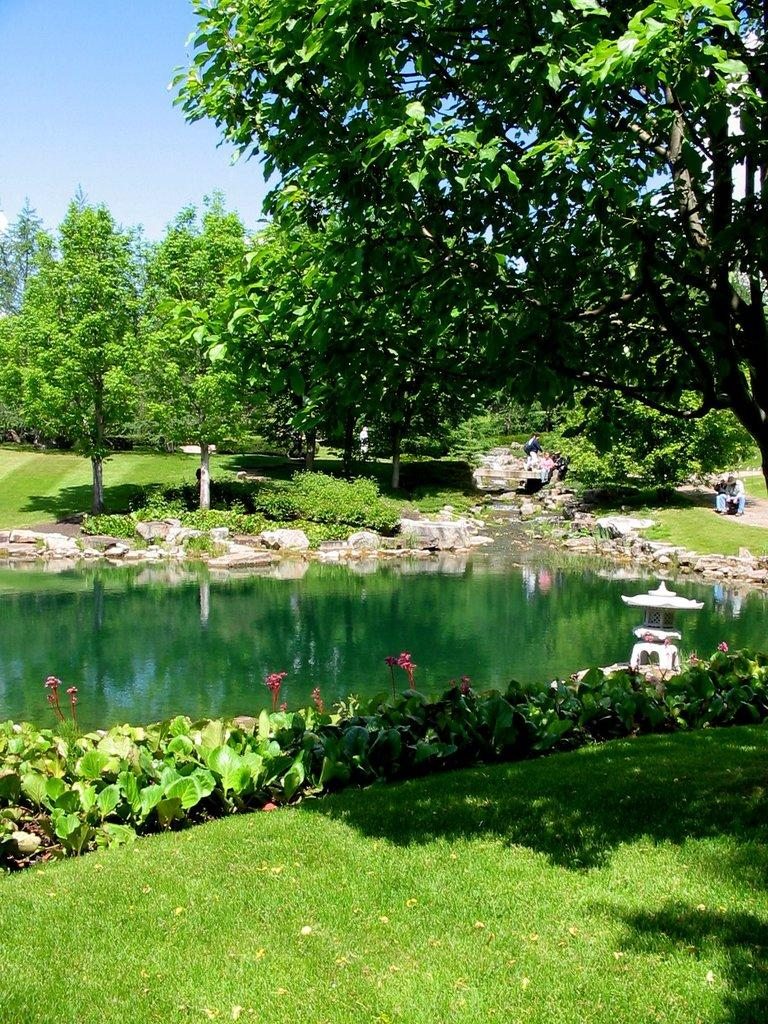What is present in the image that is not solid? There is water in the image. What types of vegetation can be seen in the image? There are plants, flowers, and trees in the image. What type of ground cover is visible in the image? There is grass in the image. Are there any people in the image? Yes, there are people in the image. What part of the natural environment is visible in the background of the image? The sky is visible in the background of the image. What type of grain can be seen growing in the image? There is no grain present in the image. Can you tell me how many knives are being used by the people in the image? There is no knife visible in the image. 